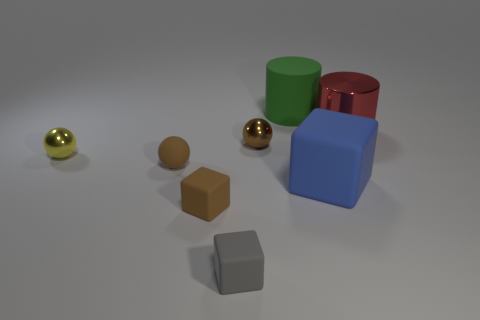Add 1 cyan metallic spheres. How many objects exist? 9 Subtract all spheres. How many objects are left? 5 Add 6 gray things. How many gray things are left? 7 Add 7 gray rubber cylinders. How many gray rubber cylinders exist? 7 Subtract 0 yellow blocks. How many objects are left? 8 Subtract all big cyan matte cubes. Subtract all green rubber objects. How many objects are left? 7 